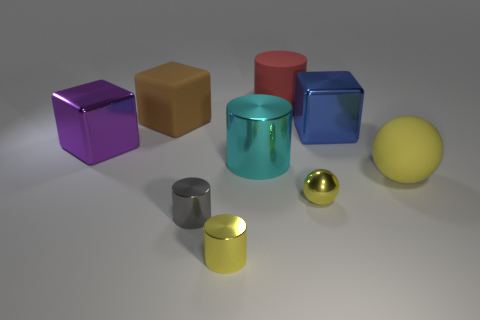Subtract all big metallic cylinders. How many cylinders are left? 3 Subtract all red cylinders. How many cylinders are left? 3 Subtract all green cylinders. Subtract all green balls. How many cylinders are left? 4 Add 1 big rubber objects. How many objects exist? 10 Subtract all spheres. How many objects are left? 7 Subtract 0 blue balls. How many objects are left? 9 Subtract all yellow cylinders. Subtract all blue things. How many objects are left? 7 Add 3 brown cubes. How many brown cubes are left? 4 Add 7 red things. How many red things exist? 8 